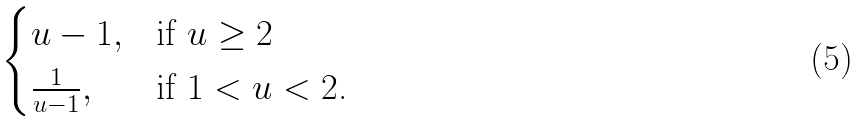Convert formula to latex. <formula><loc_0><loc_0><loc_500><loc_500>\begin{cases} u - 1 , & \text {if $u \geq 2$} \\ \frac { 1 } { u - 1 } , & \text {if $1<u<2$.} \end{cases}</formula> 